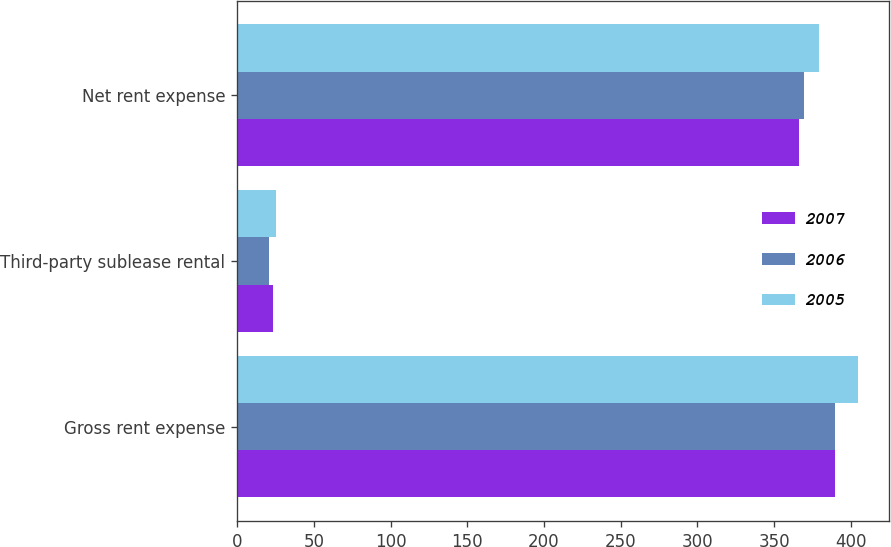Convert chart. <chart><loc_0><loc_0><loc_500><loc_500><stacked_bar_chart><ecel><fcel>Gross rent expense<fcel>Third-party sublease rental<fcel>Net rent expense<nl><fcel>2007<fcel>389.9<fcel>23.5<fcel>366.4<nl><fcel>2006<fcel>389.9<fcel>20.7<fcel>369.2<nl><fcel>2005<fcel>404.4<fcel>25.4<fcel>379<nl></chart> 